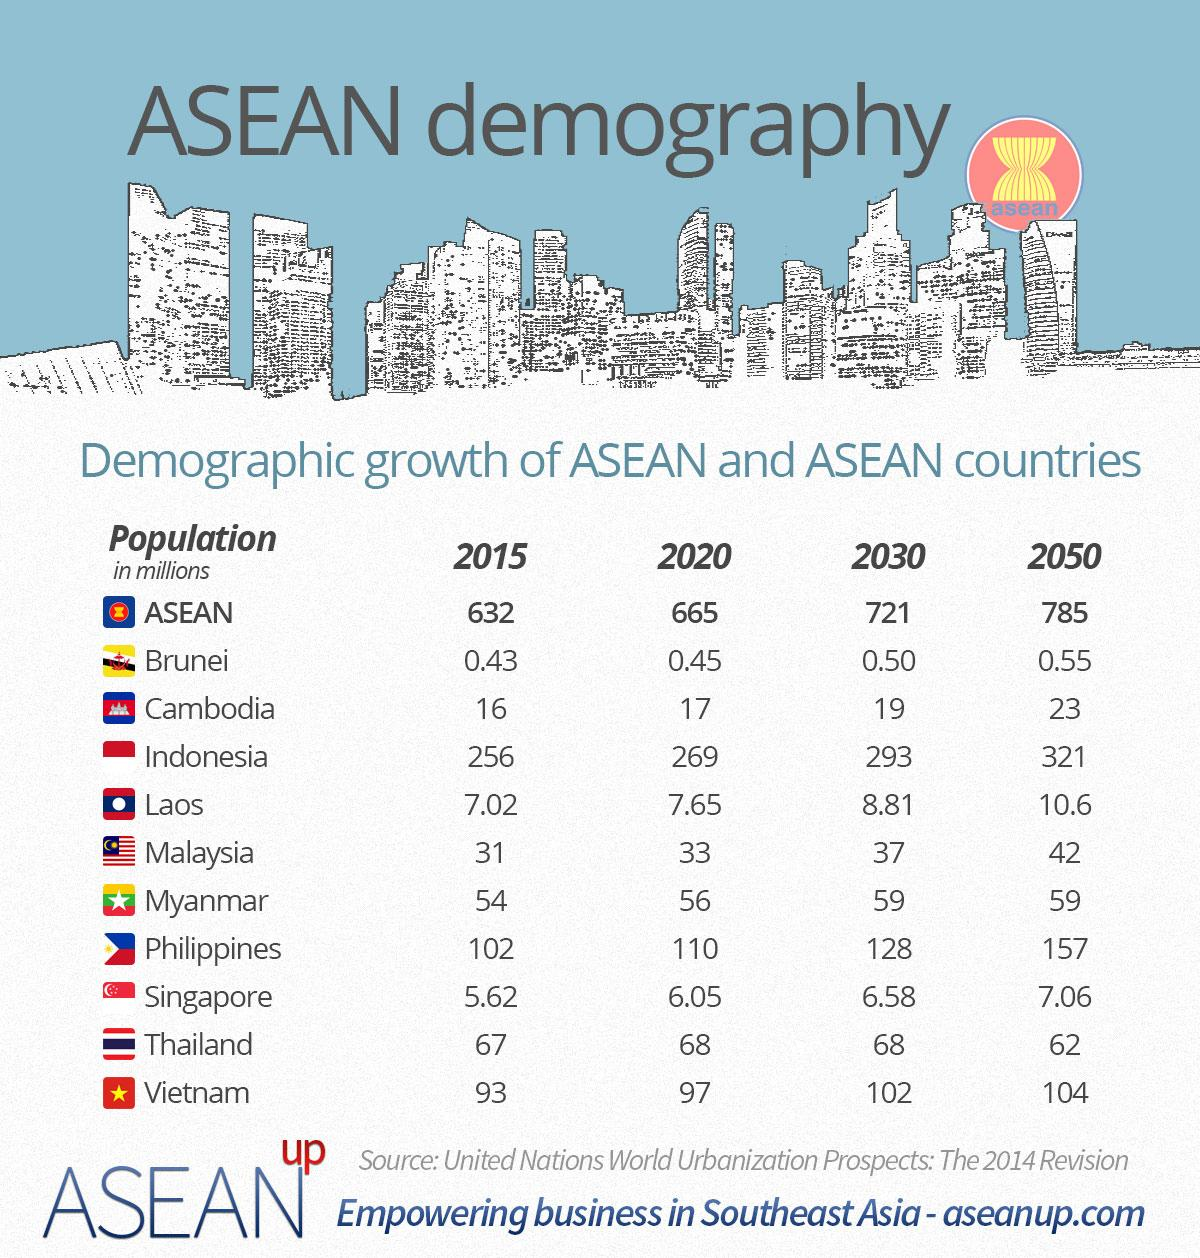List a handful of essential elements in this visual. In 2015, Brunei had the lowest population among the ASEAN countries. In 2015, Indonesia had the largest population among all ASEAN countries. According to estimates, the population of Cambodia in 2020 was approximately 17 million. There are 10 countries in ASEAN. The population of Malaysia in 2030 is estimated to be approximately 37 million. 